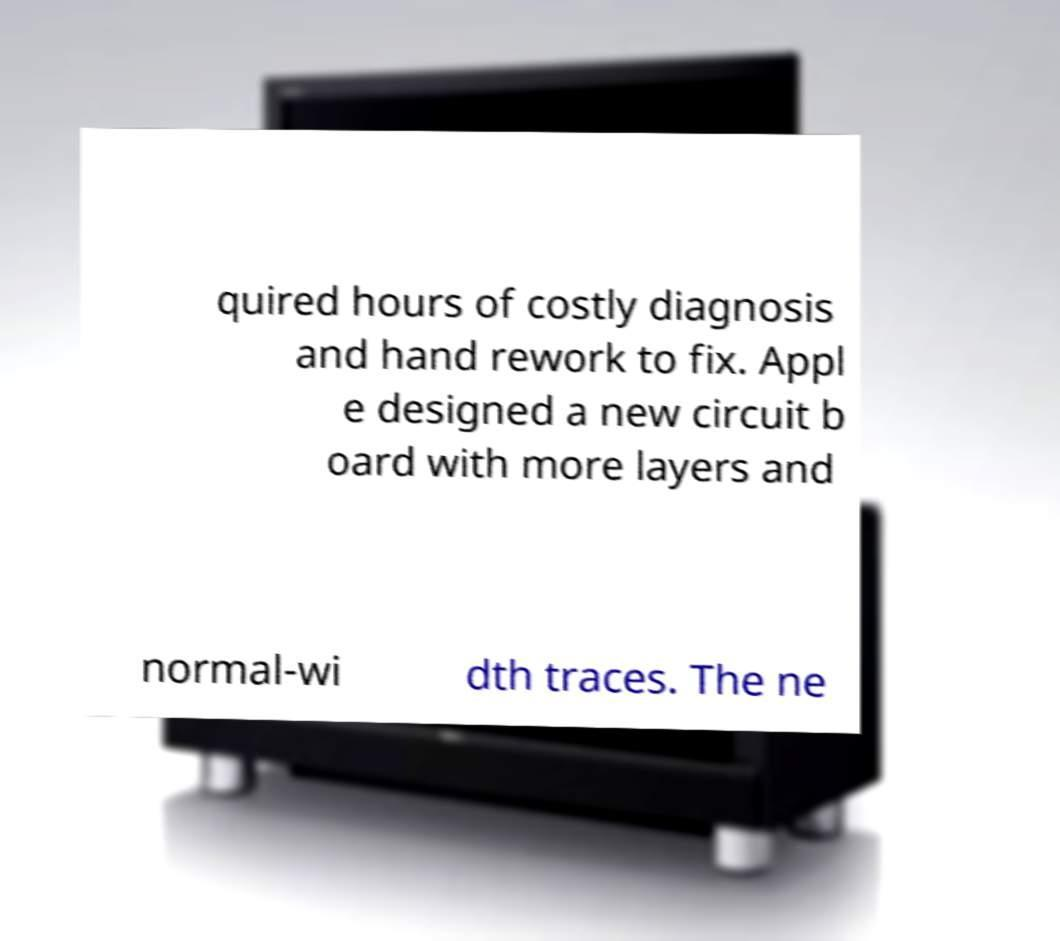Could you assist in decoding the text presented in this image and type it out clearly? quired hours of costly diagnosis and hand rework to fix. Appl e designed a new circuit b oard with more layers and normal-wi dth traces. The ne 